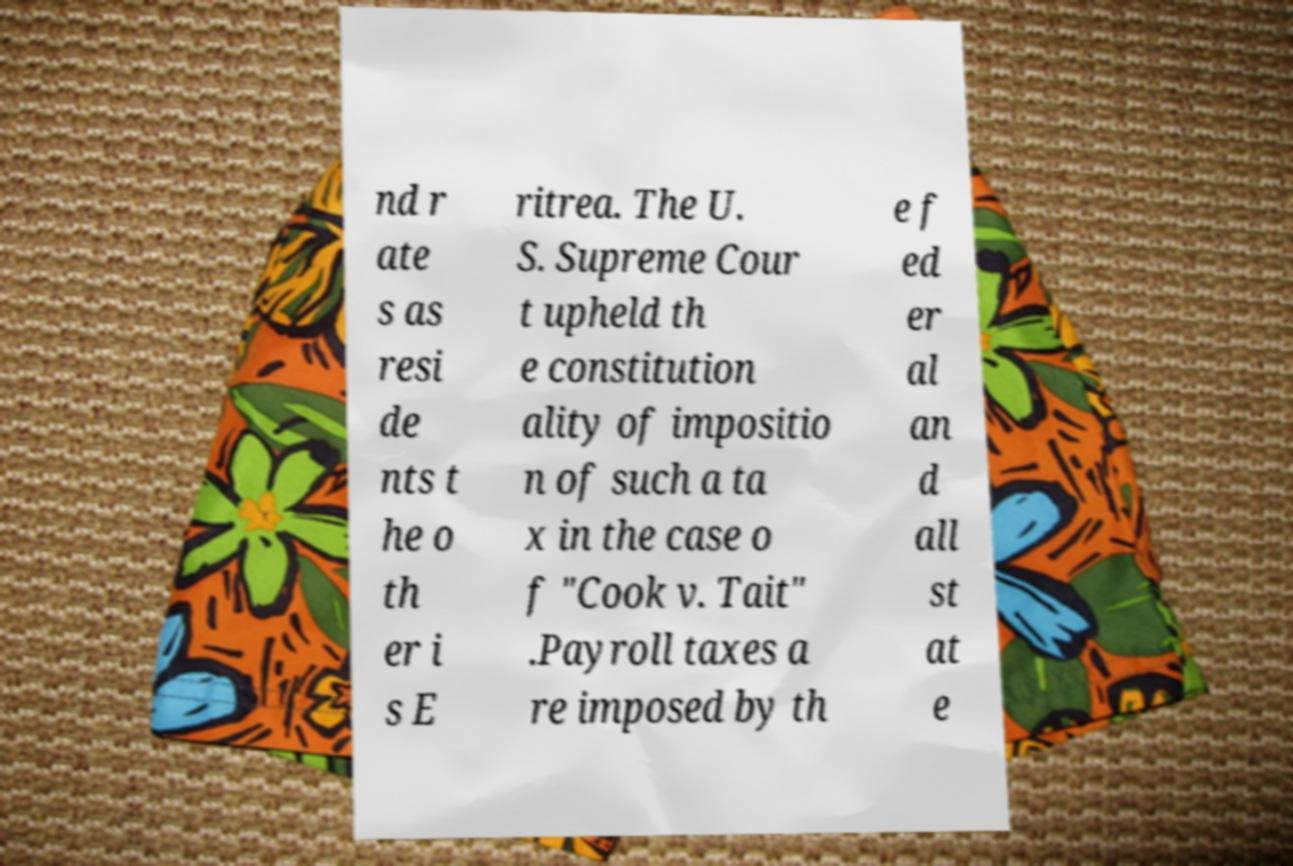I need the written content from this picture converted into text. Can you do that? nd r ate s as resi de nts t he o th er i s E ritrea. The U. S. Supreme Cour t upheld th e constitution ality of impositio n of such a ta x in the case o f "Cook v. Tait" .Payroll taxes a re imposed by th e f ed er al an d all st at e 